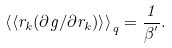<formula> <loc_0><loc_0><loc_500><loc_500>\left \langle \left \langle r _ { k } ( \partial g / \partial r _ { k } ) \right \rangle \right \rangle _ { q } = \frac { 1 } { \beta ^ { ^ { \prime } } } .</formula> 